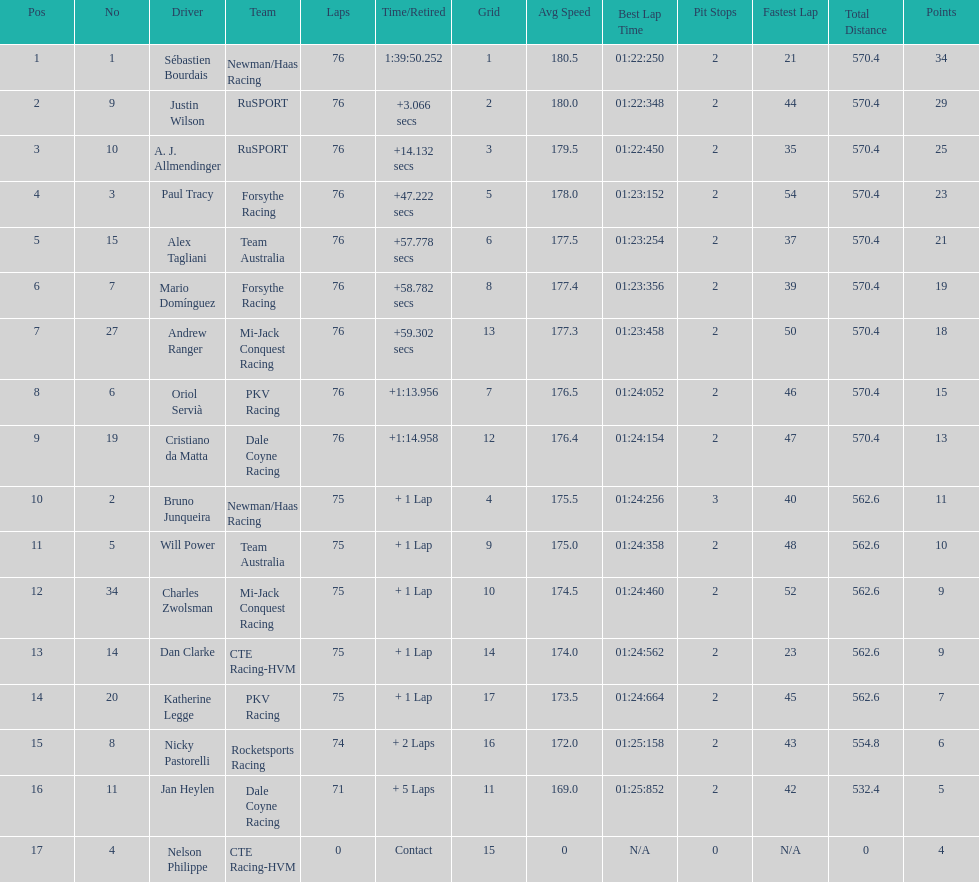What driver earned the most points? Sebastien Bourdais. 